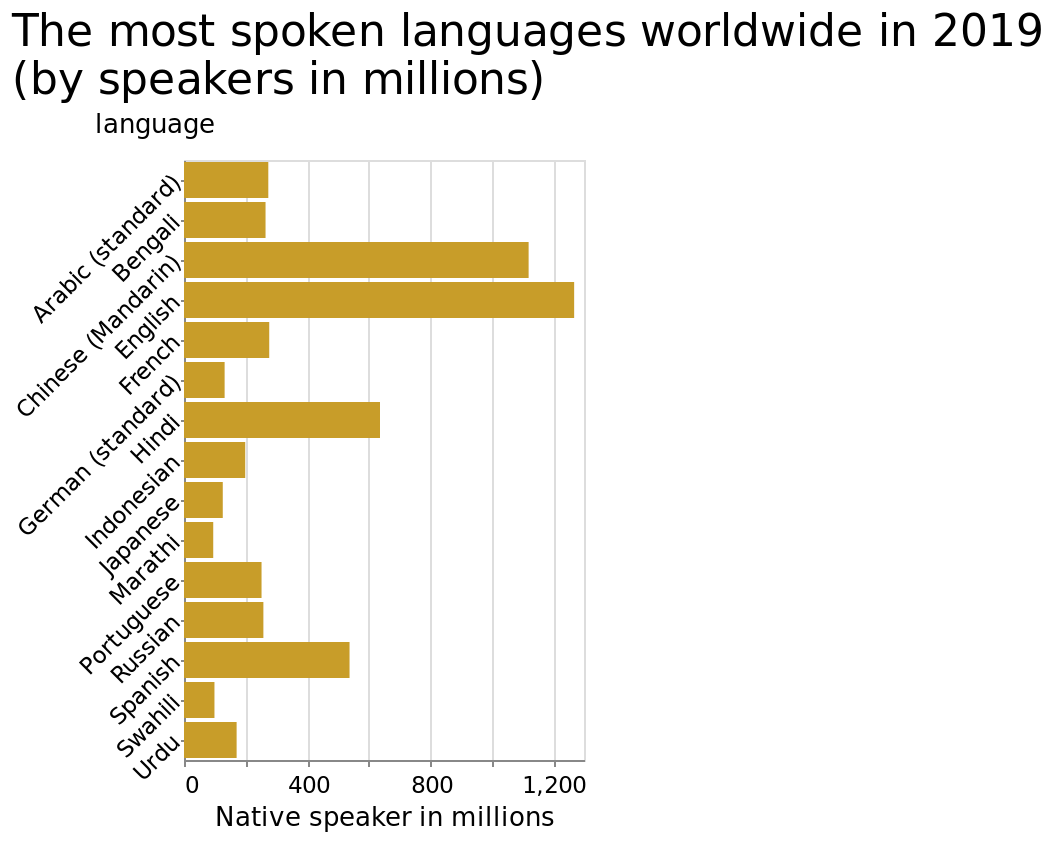<image>
please describe the details of the chart The most spoken languages worldwide in 2019 (by speakers in millions) is a bar diagram. A linear scale of range 0 to 1,200 can be found along the x-axis, labeled Native speaker in millions. The y-axis measures language with a categorical scale starting with Arabic (standard) and ending with Urdu. In terms of popularity, which language ranked first?  English. Which language was the second most popular?  Mandarin. Which language has the highest number of native speakers in millions?  The language with the highest number of native speakers in millions is Arabic (standard). What is the range of the linear scale on the x-axis of the bar diagram?  The range of the linear scale on the x-axis of the bar diagram is 0 to 1,200. Offer a thorough analysis of the image. English was the most popular language, followed by Mandarin. 